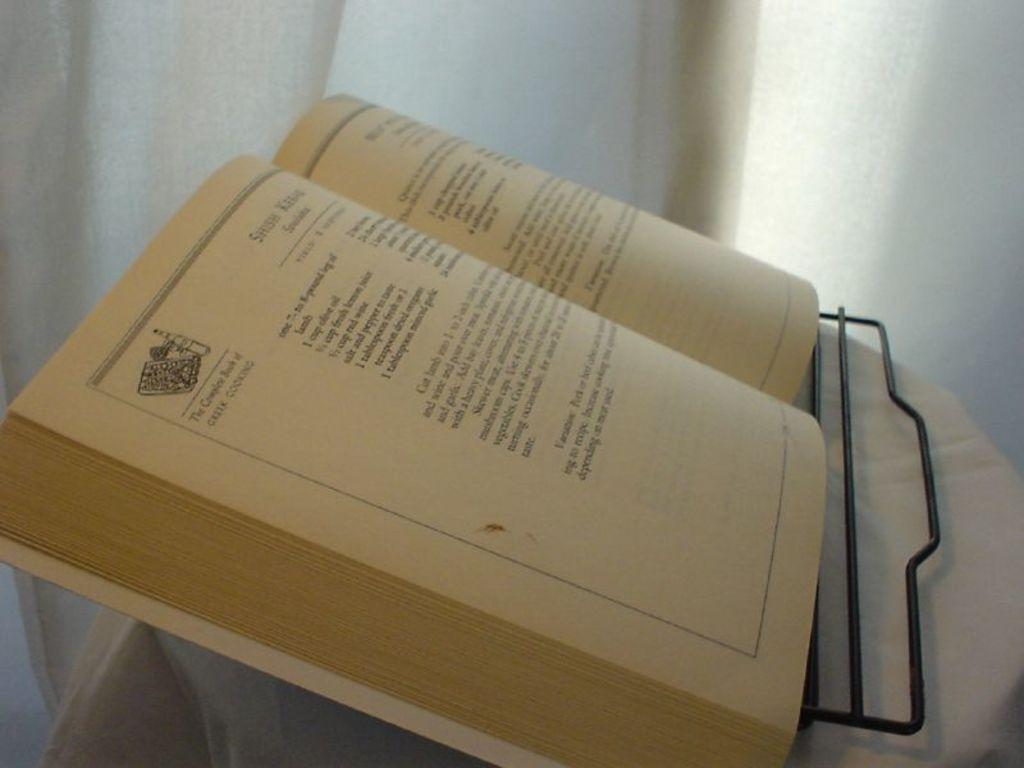<image>
Offer a succinct explanation of the picture presented. a book that is about Greek cooking and is open 